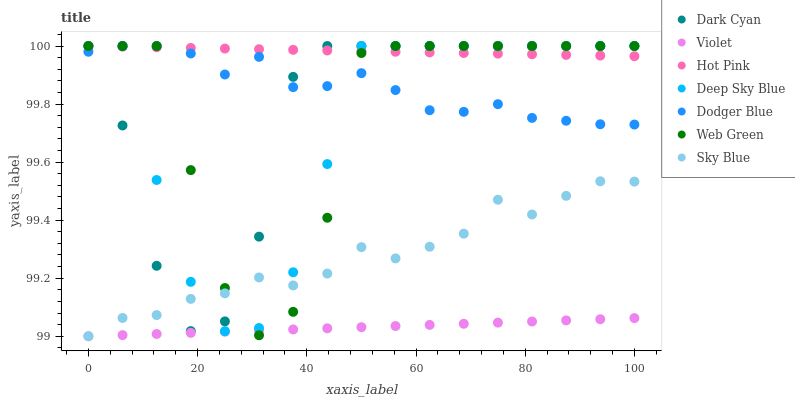Does Violet have the minimum area under the curve?
Answer yes or no. Yes. Does Hot Pink have the maximum area under the curve?
Answer yes or no. Yes. Does Web Green have the minimum area under the curve?
Answer yes or no. No. Does Web Green have the maximum area under the curve?
Answer yes or no. No. Is Hot Pink the smoothest?
Answer yes or no. Yes. Is Web Green the roughest?
Answer yes or no. Yes. Is Dodger Blue the smoothest?
Answer yes or no. No. Is Dodger Blue the roughest?
Answer yes or no. No. Does Violet have the lowest value?
Answer yes or no. Yes. Does Web Green have the lowest value?
Answer yes or no. No. Does Dark Cyan have the highest value?
Answer yes or no. Yes. Does Violet have the highest value?
Answer yes or no. No. Is Violet less than Dark Cyan?
Answer yes or no. Yes. Is Hot Pink greater than Violet?
Answer yes or no. Yes. Does Sky Blue intersect Web Green?
Answer yes or no. Yes. Is Sky Blue less than Web Green?
Answer yes or no. No. Is Sky Blue greater than Web Green?
Answer yes or no. No. Does Violet intersect Dark Cyan?
Answer yes or no. No. 